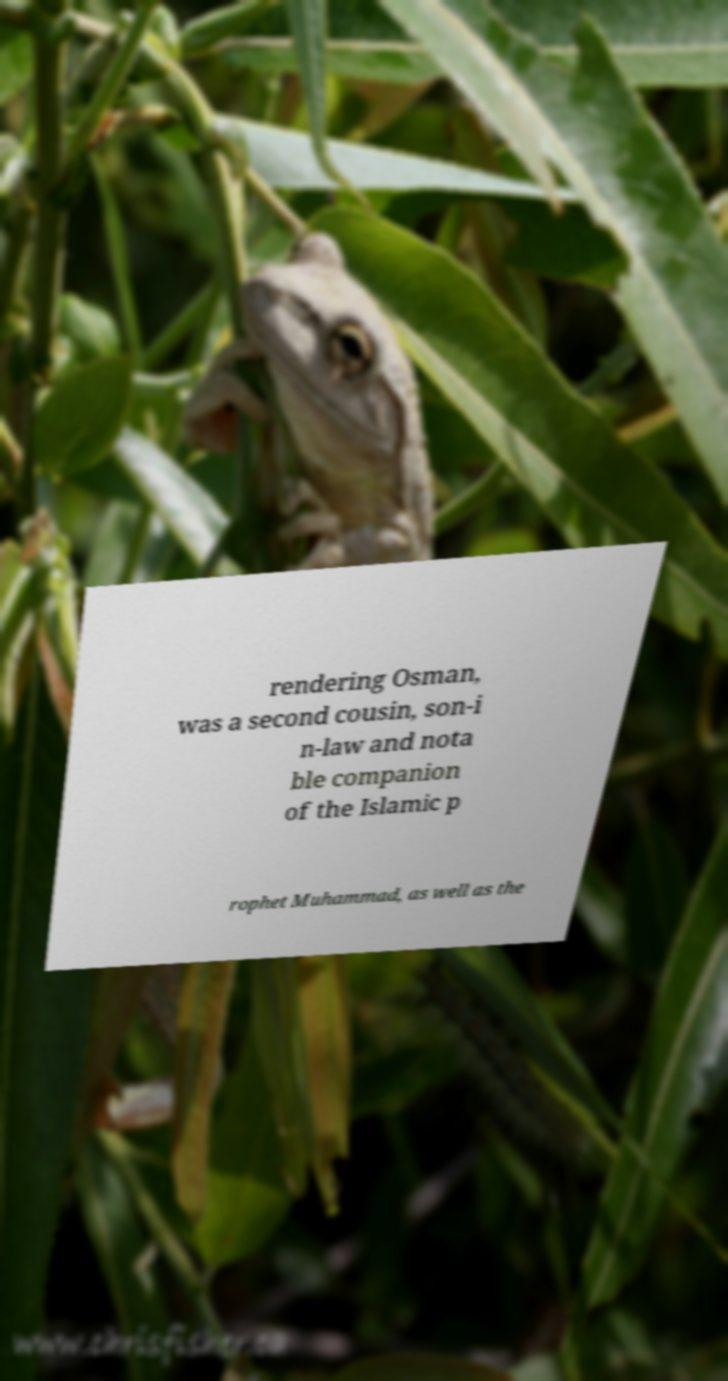What messages or text are displayed in this image? I need them in a readable, typed format. rendering Osman, was a second cousin, son-i n-law and nota ble companion of the Islamic p rophet Muhammad, as well as the 